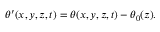Convert formula to latex. <formula><loc_0><loc_0><loc_500><loc_500>\begin{array} { r } { \theta ^ { \prime } ( x , y , z , t ) = \theta ( x , y , z , t ) - \theta _ { 0 } ( z ) . } \end{array}</formula> 